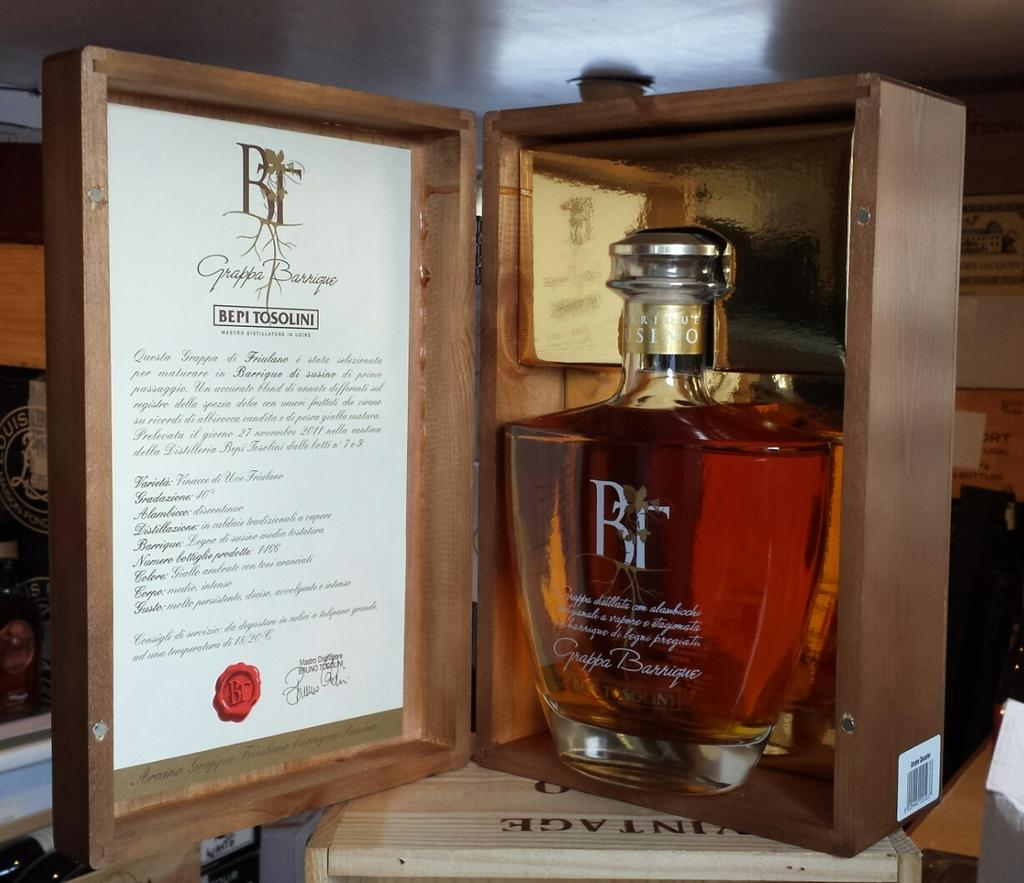<image>
Provide a brief description of the given image. A bottle of BR is in the items original box. 